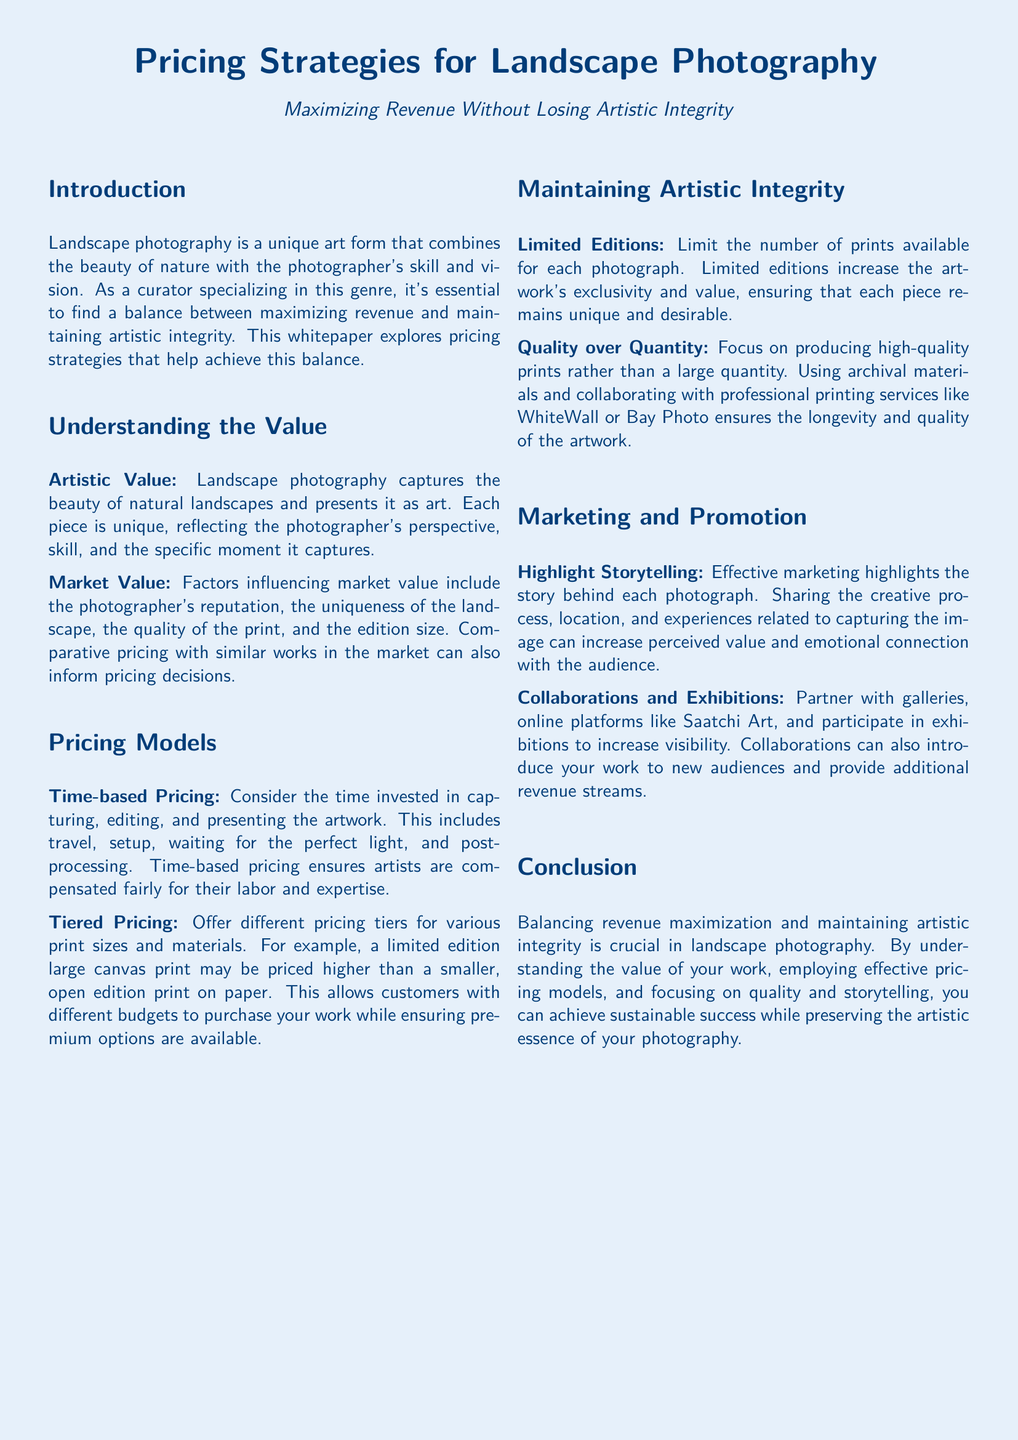What is the title of the whitepaper? The title is provided at the beginning of the document, clearly stating the focus on pricing strategies in landscape photography.
Answer: Pricing Strategies for Landscape Photography What are two types of value discussed in the document? The document mentions two types of value that are important for pricing: artistic value and market value.
Answer: Artistic Value, Market Value What pricing model is mentioned that considers time invested by the photographer? The document specifies a pricing model that factors in the photographer's time spent on various processes, which is important for fair compensation.
Answer: Time-based Pricing How does the document suggest maintaining exclusivity in artwork? The document recommends limiting the number of prints available for each photograph to enhance uniqueness and desirability.
Answer: Limited Editions Which printing services does the document recommend for quality? The whitepaper suggests collaborating with professional printing services to ensure high-quality prints for landscape photography.
Answer: WhiteWall, Bay Photo What is a key marketing strategy highlighted in the document? The document emphasizes the importance of storytelling in marketing landscape photography to enhance value and connect with the audience.
Answer: Highlight Storytelling What aspect does the whitepaper advise focusing on to achieve sustainable success? The conclusion of the document underscores the balance between revenue maximization and maintaining artistic integrity as vital for long-term success.
Answer: Balancing revenue maximization and maintaining artistic integrity 